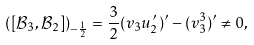Convert formula to latex. <formula><loc_0><loc_0><loc_500><loc_500>\left ( [ \mathcal { B } _ { 3 } , \mathcal { B } _ { 2 } ] \right ) _ { - \frac { 1 } { 2 } } = \frac { 3 } { 2 } ( v _ { 3 } u ^ { \prime } _ { 2 } ) ^ { \prime } - ( v _ { 3 } ^ { 3 } ) ^ { \prime } \neq 0 ,</formula> 